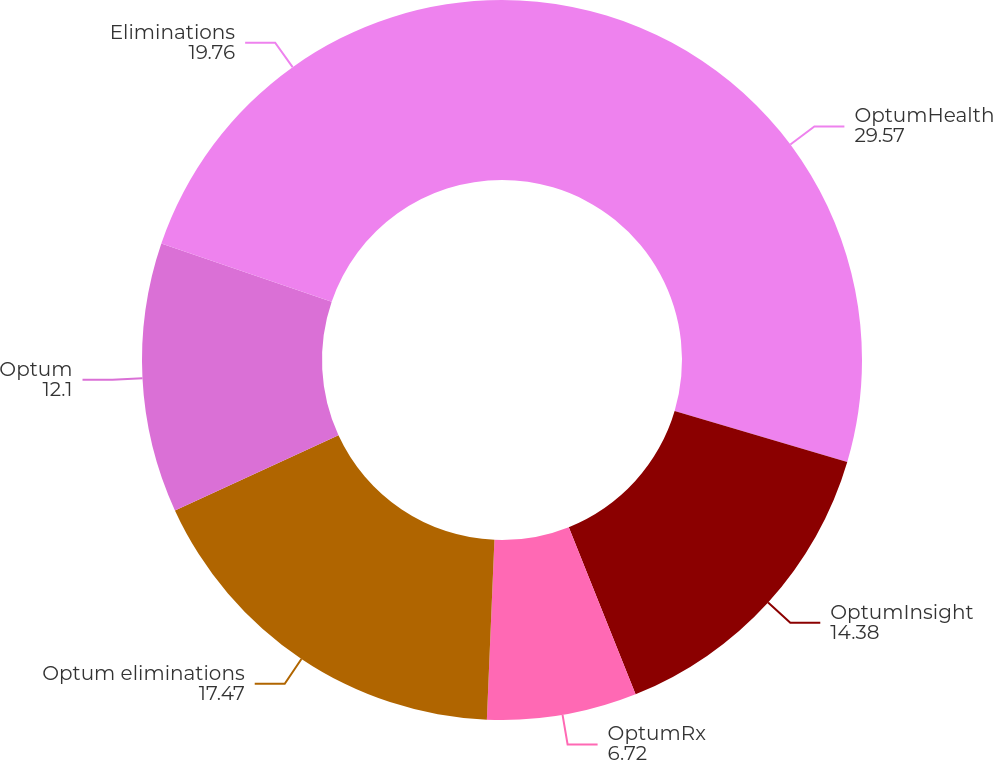Convert chart to OTSL. <chart><loc_0><loc_0><loc_500><loc_500><pie_chart><fcel>OptumHealth<fcel>OptumInsight<fcel>OptumRx<fcel>Optum eliminations<fcel>Optum<fcel>Eliminations<nl><fcel>29.57%<fcel>14.38%<fcel>6.72%<fcel>17.47%<fcel>12.1%<fcel>19.76%<nl></chart> 